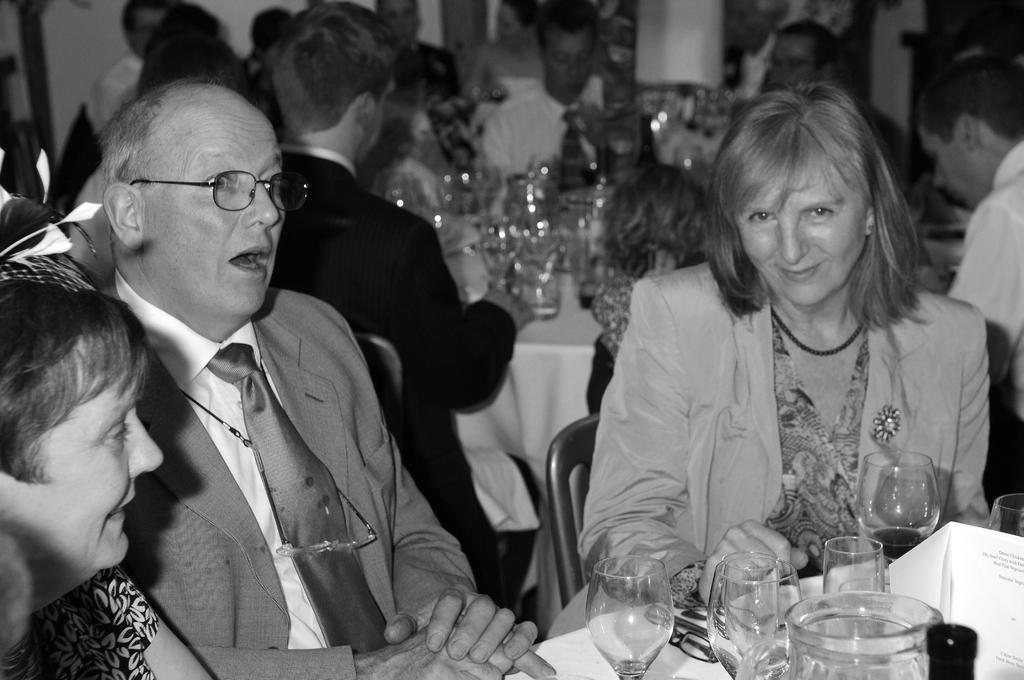How would you summarize this image in a sentence or two? This is a black and white image. There are a few people sitting on chairs. We can see some tables covered with a cloth and some objects like glasses are placed on it. We can also see the wall. 